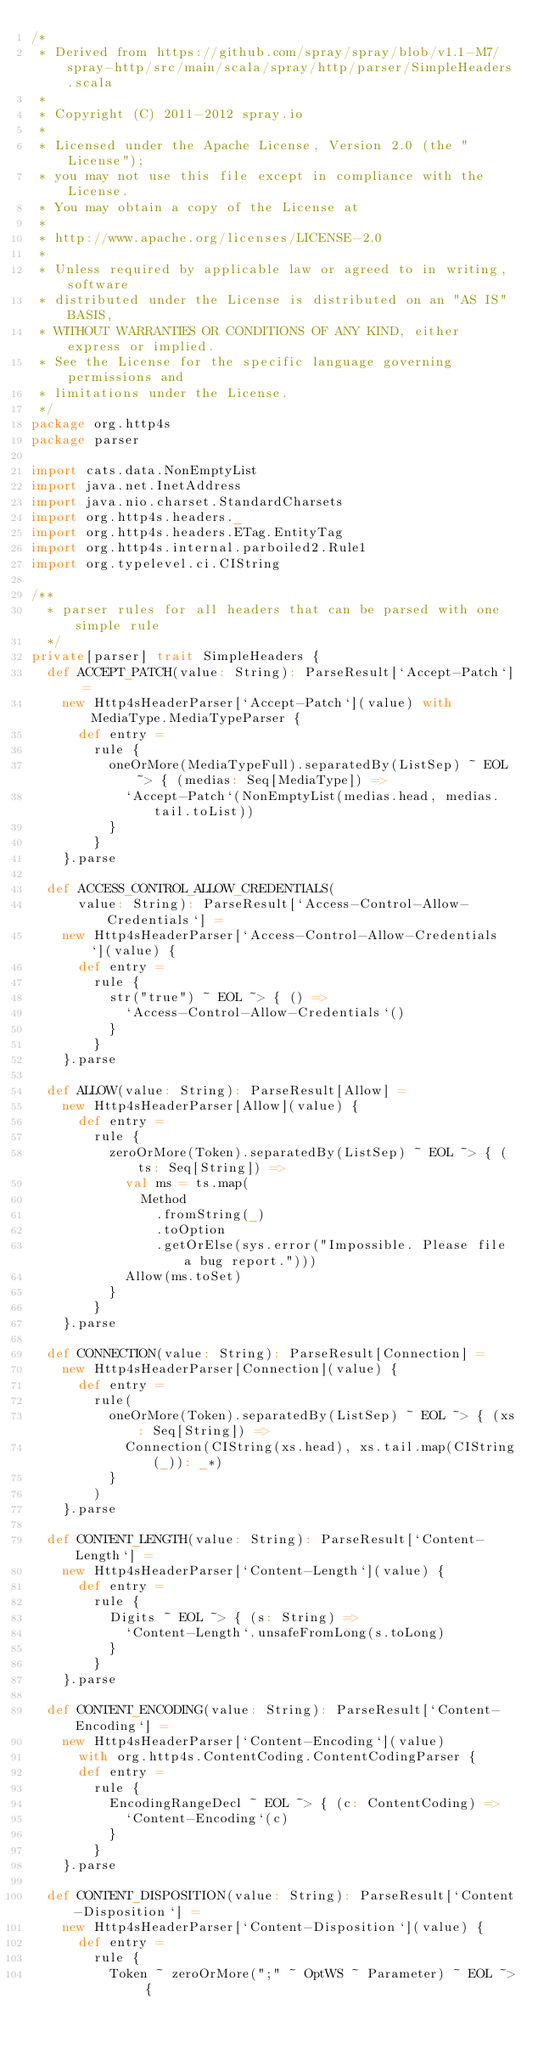Convert code to text. <code><loc_0><loc_0><loc_500><loc_500><_Scala_>/*
 * Derived from https://github.com/spray/spray/blob/v1.1-M7/spray-http/src/main/scala/spray/http/parser/SimpleHeaders.scala
 *
 * Copyright (C) 2011-2012 spray.io
 *
 * Licensed under the Apache License, Version 2.0 (the "License");
 * you may not use this file except in compliance with the License.
 * You may obtain a copy of the License at
 *
 * http://www.apache.org/licenses/LICENSE-2.0
 *
 * Unless required by applicable law or agreed to in writing, software
 * distributed under the License is distributed on an "AS IS" BASIS,
 * WITHOUT WARRANTIES OR CONDITIONS OF ANY KIND, either express or implied.
 * See the License for the specific language governing permissions and
 * limitations under the License.
 */
package org.http4s
package parser

import cats.data.NonEmptyList
import java.net.InetAddress
import java.nio.charset.StandardCharsets
import org.http4s.headers._
import org.http4s.headers.ETag.EntityTag
import org.http4s.internal.parboiled2.Rule1
import org.typelevel.ci.CIString

/**
  * parser rules for all headers that can be parsed with one simple rule
  */
private[parser] trait SimpleHeaders {
  def ACCEPT_PATCH(value: String): ParseResult[`Accept-Patch`] =
    new Http4sHeaderParser[`Accept-Patch`](value) with MediaType.MediaTypeParser {
      def entry =
        rule {
          oneOrMore(MediaTypeFull).separatedBy(ListSep) ~ EOL ~> { (medias: Seq[MediaType]) =>
            `Accept-Patch`(NonEmptyList(medias.head, medias.tail.toList))
          }
        }
    }.parse

  def ACCESS_CONTROL_ALLOW_CREDENTIALS(
      value: String): ParseResult[`Access-Control-Allow-Credentials`] =
    new Http4sHeaderParser[`Access-Control-Allow-Credentials`](value) {
      def entry =
        rule {
          str("true") ~ EOL ~> { () =>
            `Access-Control-Allow-Credentials`()
          }
        }
    }.parse

  def ALLOW(value: String): ParseResult[Allow] =
    new Http4sHeaderParser[Allow](value) {
      def entry =
        rule {
          zeroOrMore(Token).separatedBy(ListSep) ~ EOL ~> { (ts: Seq[String]) =>
            val ms = ts.map(
              Method
                .fromString(_)
                .toOption
                .getOrElse(sys.error("Impossible. Please file a bug report.")))
            Allow(ms.toSet)
          }
        }
    }.parse

  def CONNECTION(value: String): ParseResult[Connection] =
    new Http4sHeaderParser[Connection](value) {
      def entry =
        rule(
          oneOrMore(Token).separatedBy(ListSep) ~ EOL ~> { (xs: Seq[String]) =>
            Connection(CIString(xs.head), xs.tail.map(CIString(_)): _*)
          }
        )
    }.parse

  def CONTENT_LENGTH(value: String): ParseResult[`Content-Length`] =
    new Http4sHeaderParser[`Content-Length`](value) {
      def entry =
        rule {
          Digits ~ EOL ~> { (s: String) =>
            `Content-Length`.unsafeFromLong(s.toLong)
          }
        }
    }.parse

  def CONTENT_ENCODING(value: String): ParseResult[`Content-Encoding`] =
    new Http4sHeaderParser[`Content-Encoding`](value)
      with org.http4s.ContentCoding.ContentCodingParser {
      def entry =
        rule {
          EncodingRangeDecl ~ EOL ~> { (c: ContentCoding) =>
            `Content-Encoding`(c)
          }
        }
    }.parse

  def CONTENT_DISPOSITION(value: String): ParseResult[`Content-Disposition`] =
    new Http4sHeaderParser[`Content-Disposition`](value) {
      def entry =
        rule {
          Token ~ zeroOrMore(";" ~ OptWS ~ Parameter) ~ EOL ~> {</code> 